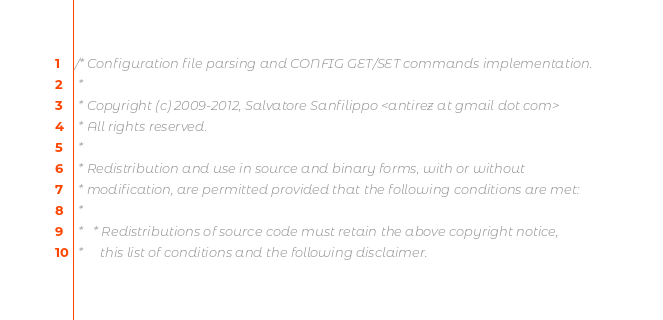Convert code to text. <code><loc_0><loc_0><loc_500><loc_500><_C_>/* Configuration file parsing and CONFIG GET/SET commands implementation.
 *
 * Copyright (c) 2009-2012, Salvatore Sanfilippo <antirez at gmail dot com>
 * All rights reserved.
 *
 * Redistribution and use in source and binary forms, with or without
 * modification, are permitted provided that the following conditions are met:
 *
 *   * Redistributions of source code must retain the above copyright notice,
 *     this list of conditions and the following disclaimer.</code> 